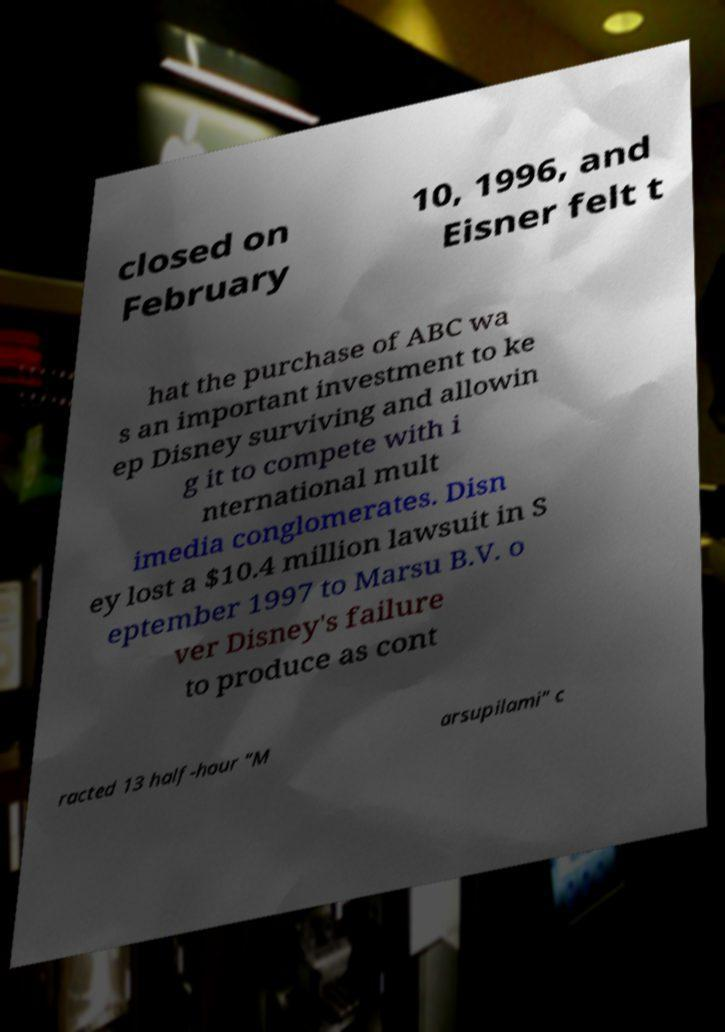Can you accurately transcribe the text from the provided image for me? closed on February 10, 1996, and Eisner felt t hat the purchase of ABC wa s an important investment to ke ep Disney surviving and allowin g it to compete with i nternational mult imedia conglomerates. Disn ey lost a $10.4 million lawsuit in S eptember 1997 to Marsu B.V. o ver Disney's failure to produce as cont racted 13 half-hour "M arsupilami" c 